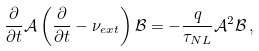<formula> <loc_0><loc_0><loc_500><loc_500>\frac { \partial } { \partial t } \mathcal { A } \left ( \frac { \partial } { \partial t } - \nu _ { e x t } \right ) \mathcal { B } = - \frac { q } { \tau _ { N L } } \mathcal { A } ^ { 2 } \mathcal { B } \, ,</formula> 